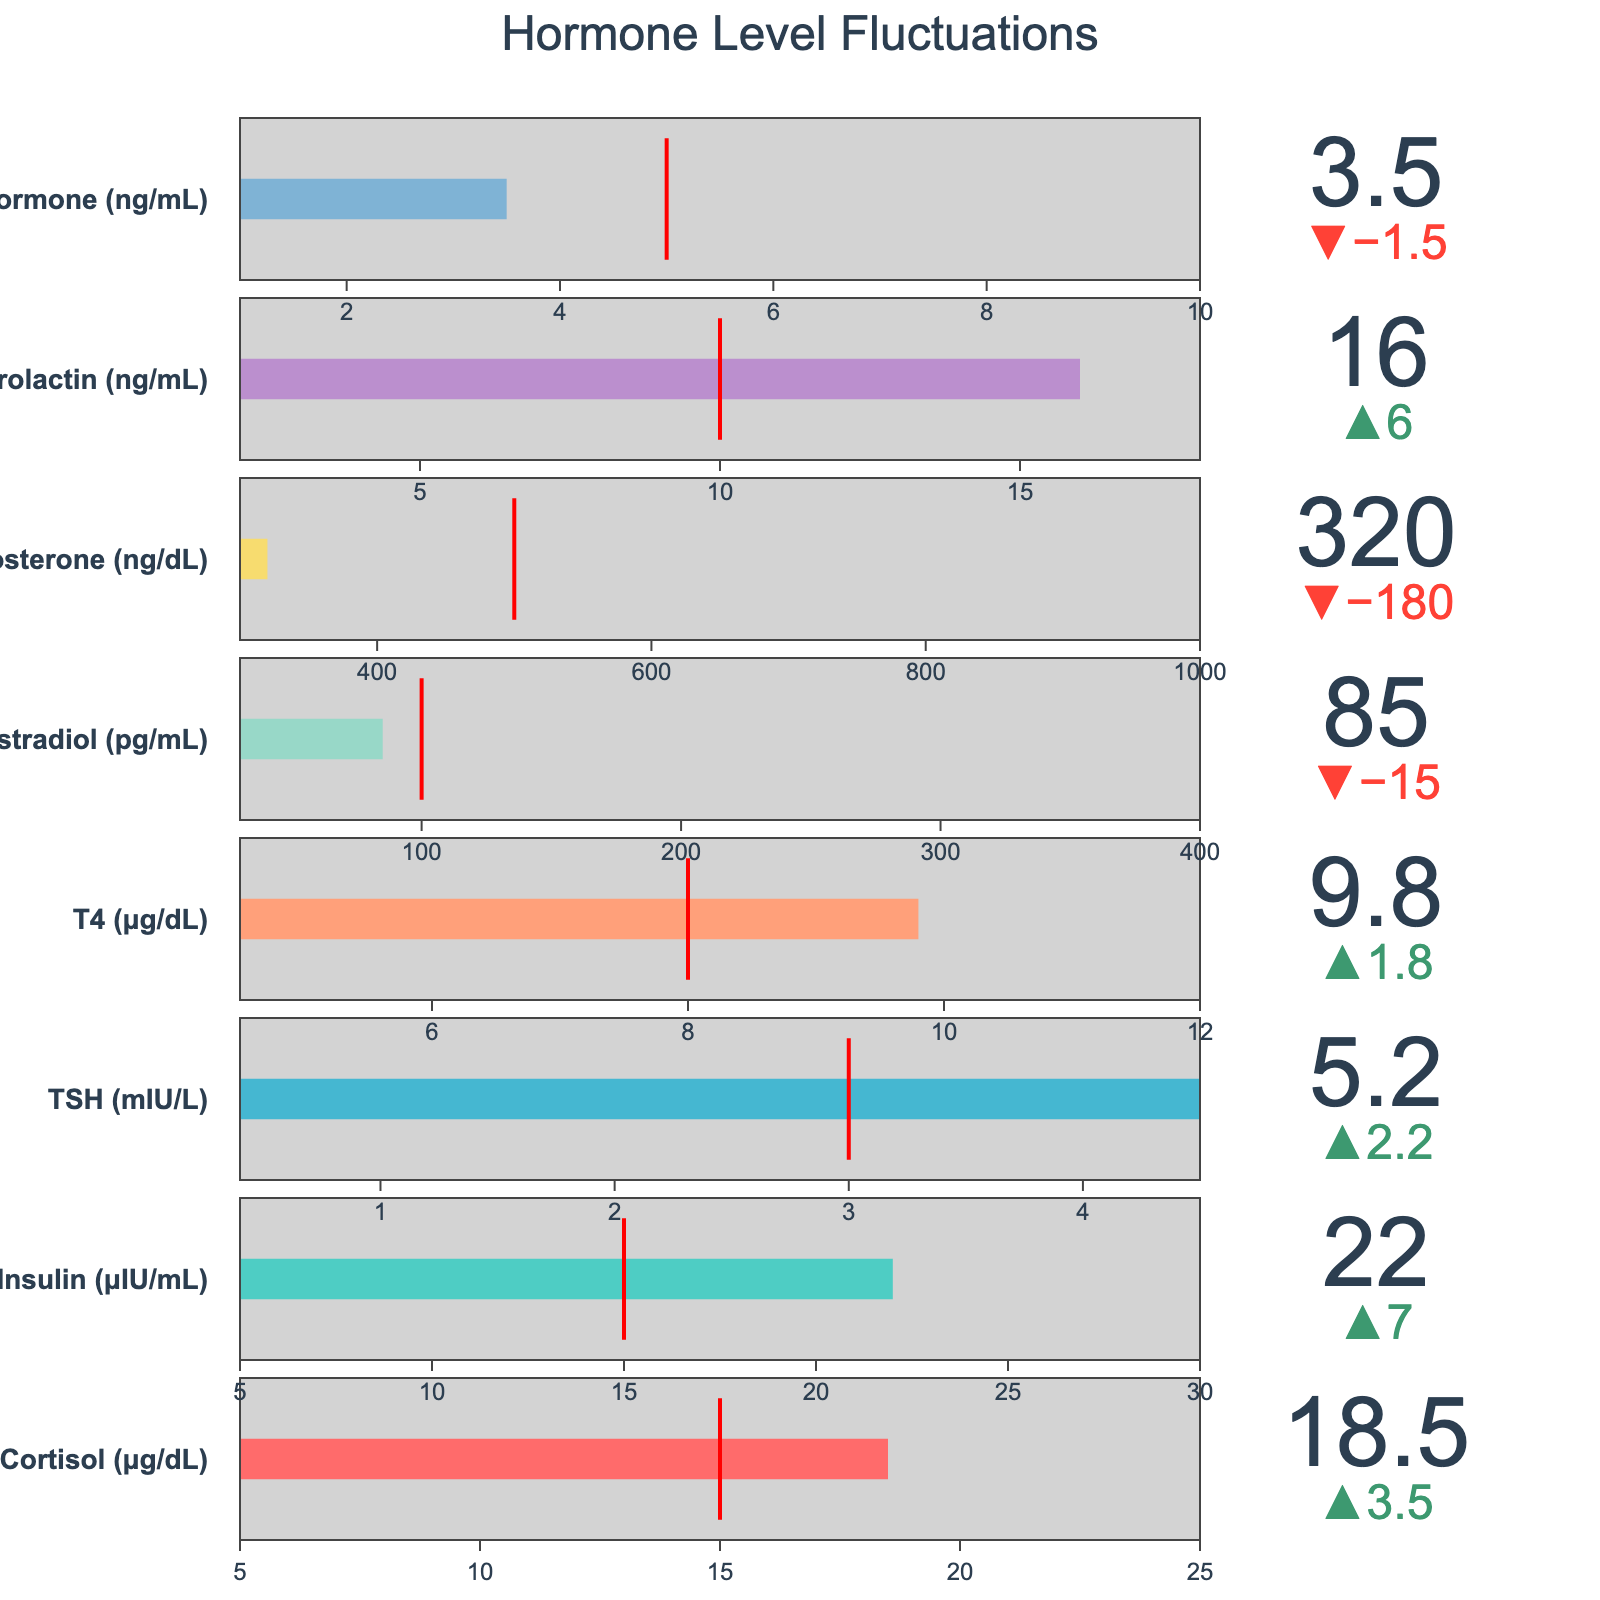What is the title of the figure? The title can be found at the top of the figure. It reads "Hormone Level Fluctuations."
Answer: Hormone Level Fluctuations Which hormone has the highest actual value? Look at the bars representing the actual values for each hormone. The hormone with the longest bar is Cortisol with an actual value of 18.5.
Answer: Cortisol What is the actual value of Growth Hormone in ng/mL? Locate the section for Growth Hormone. The actual value indicated by the bar is 3.5 ng/mL.
Answer: 3.5 Which two hormones have actual values below the target values? Compare the actual values with the target values for each hormone. Estradiol and Testosterone have actual values below their targets.
Answer: Estradiol, Testosterone Which hormone has the smallest range based on the range start and range end values? Calculate the range for each hormone by subtracting the range start from the range end. TSH has the smallest range (4.5 - 0.4 = 4.1).
Answer: TSH How much higher is the actual value of Insulin compared to its target value? Subtract the target value (15) from the actual value (22) for Insulin. The difference is 22 - 15 = 7.
Answer: 7 Which hormone has the closest actual value to its target value? Compare the actual values and target values for each hormone. Cortisol has an actual value of 18.5 and a target of 15, with a difference of 3.5, which is the smallest among all differences.
Answer: Cortisol What is the difference between the highest and the lowest actual values? Identify the highest actual value (Cortisol at 18.5) and the lowest actual value (Growth Hormone at 3.5). The difference is 18.5 - 3.5 = 15.
Answer: 15 Which hormone has an actual value outside its range? Compare the actual values to their respective range start and range end values. TSH has an actual value of 5.2, which is outside its range of 0.4 to 4.5.
Answer: TSH How many hormones have their actual values within their target ranges? Compare the actual values to the range starts and ends for each hormone. Those within their ranges are Cortisol, Insulin, T4, Estradiol, Testosterone, Prolactin, and Growth Hormone. There are 7 hormones.
Answer: 7 